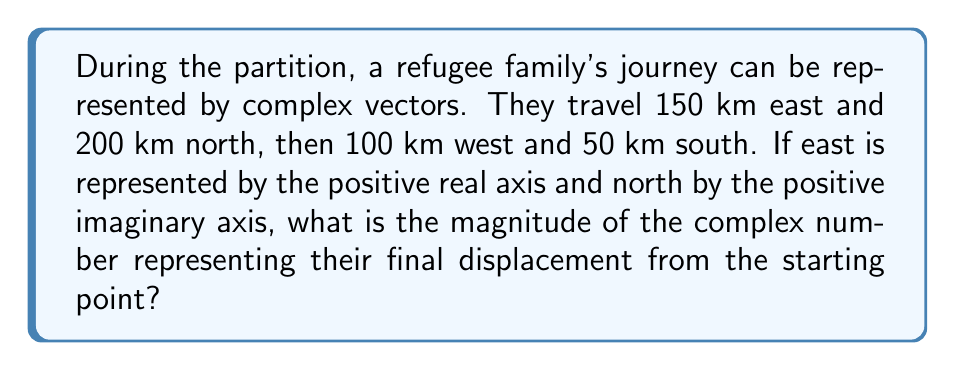Can you answer this question? Let's approach this step-by-step:

1) First, we need to represent each movement as a complex number:
   - 150 km east: $150 + 0i$
   - 200 km north: $0 + 200i$
   - 100 km west: $-100 + 0i$
   - 50 km south: $0 - 50i$

2) Now, we sum these complex numbers to get the total displacement:
   $$(150 + 0i) + (0 + 200i) + (-100 + 0i) + (0 - 50i)$$

3) Simplifying:
   $$50 + 150i$$

4) This complex number represents the final displacement from the starting point.

5) To find the magnitude of this complex number, we use the formula:
   $$|a + bi| = \sqrt{a^2 + b^2}$$

6) Substituting our values:
   $$|50 + 150i| = \sqrt{50^2 + 150^2}$$

7) Calculating:
   $$\sqrt{2500 + 22500} = \sqrt{25000} = 5\sqrt{1000} \approx 158.11$$

Therefore, the magnitude of the displacement is approximately 158.11 km.
Answer: $5\sqrt{1000}$ km $\approx 158.11$ km 